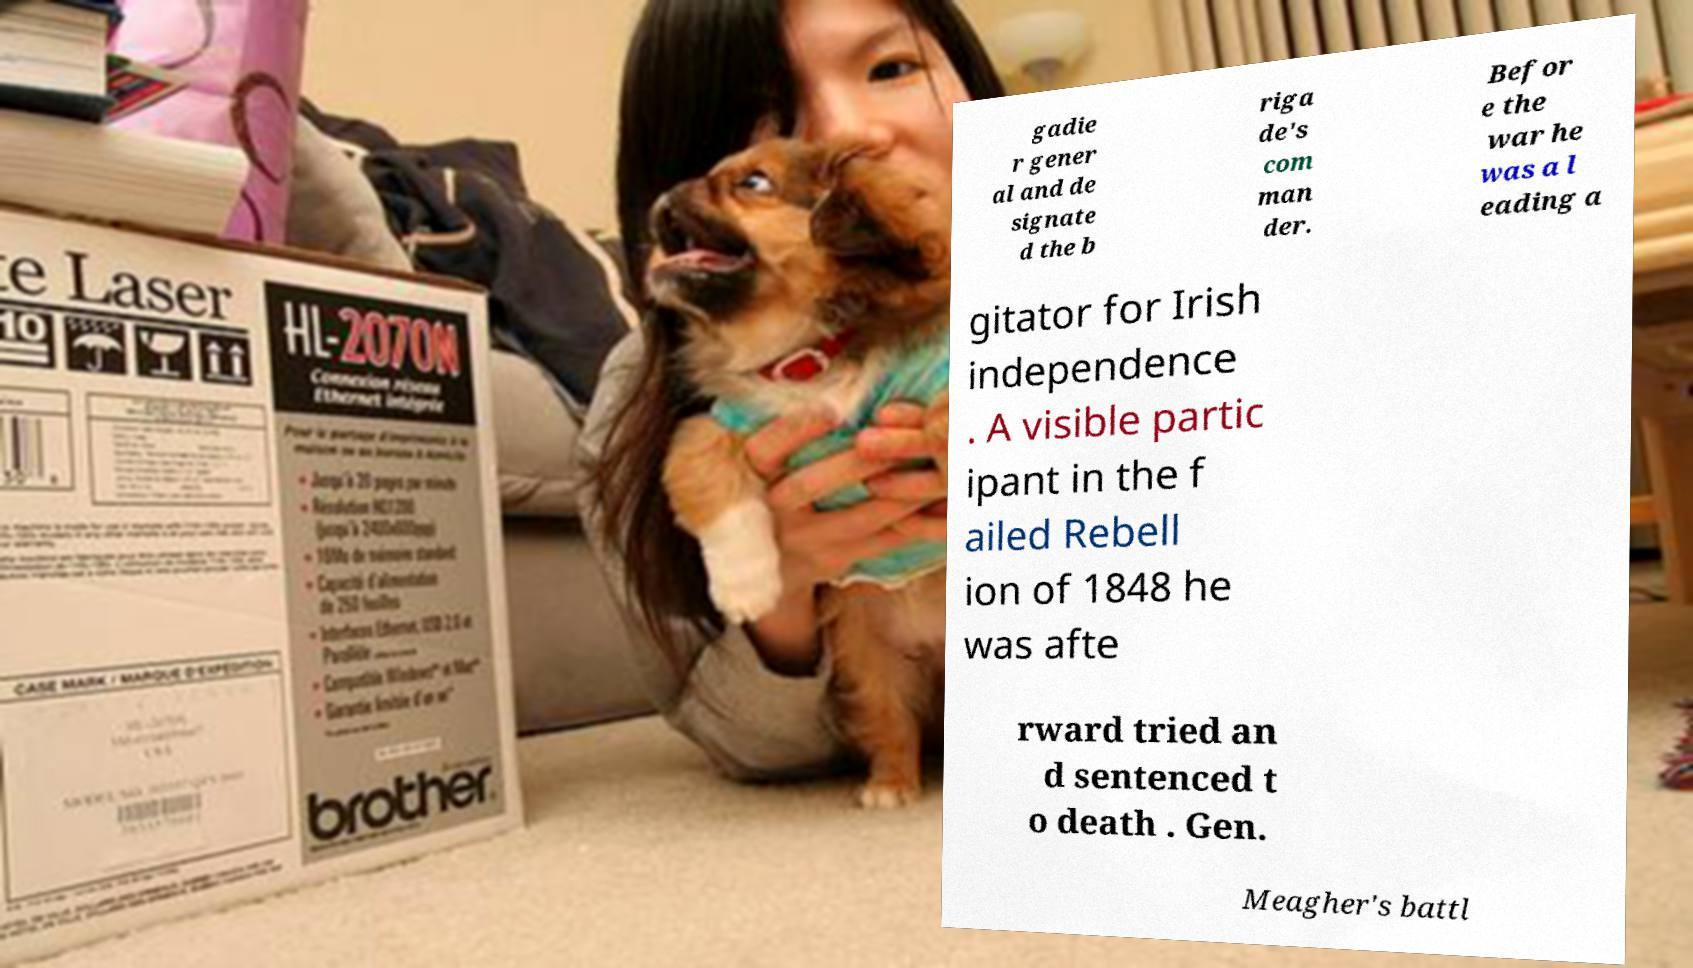Could you assist in decoding the text presented in this image and type it out clearly? gadie r gener al and de signate d the b riga de's com man der. Befor e the war he was a l eading a gitator for Irish independence . A visible partic ipant in the f ailed Rebell ion of 1848 he was afte rward tried an d sentenced t o death . Gen. Meagher's battl 